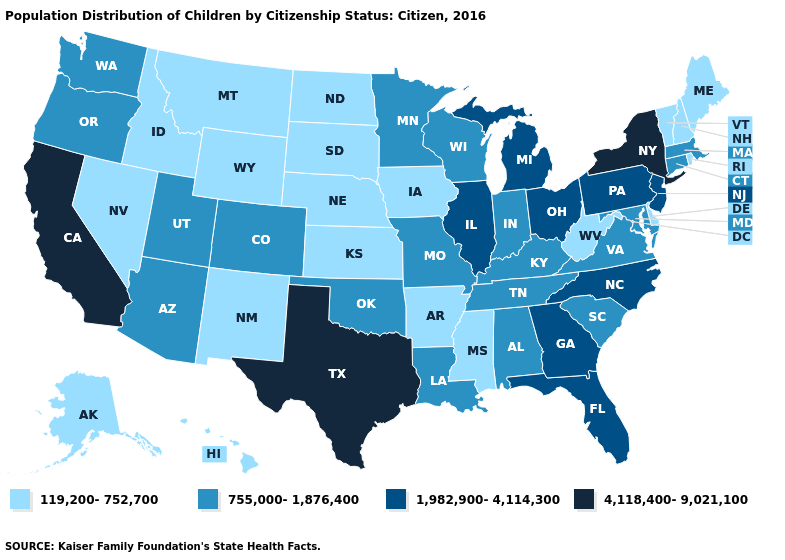Name the states that have a value in the range 755,000-1,876,400?
Write a very short answer. Alabama, Arizona, Colorado, Connecticut, Indiana, Kentucky, Louisiana, Maryland, Massachusetts, Minnesota, Missouri, Oklahoma, Oregon, South Carolina, Tennessee, Utah, Virginia, Washington, Wisconsin. What is the value of New Mexico?
Give a very brief answer. 119,200-752,700. Does Georgia have the same value as New York?
Keep it brief. No. What is the highest value in the West ?
Write a very short answer. 4,118,400-9,021,100. Name the states that have a value in the range 4,118,400-9,021,100?
Write a very short answer. California, New York, Texas. Does Ohio have the highest value in the MidWest?
Be succinct. Yes. Does Idaho have the lowest value in the West?
Give a very brief answer. Yes. Which states have the lowest value in the USA?
Concise answer only. Alaska, Arkansas, Delaware, Hawaii, Idaho, Iowa, Kansas, Maine, Mississippi, Montana, Nebraska, Nevada, New Hampshire, New Mexico, North Dakota, Rhode Island, South Dakota, Vermont, West Virginia, Wyoming. Name the states that have a value in the range 4,118,400-9,021,100?
Short answer required. California, New York, Texas. What is the value of Connecticut?
Be succinct. 755,000-1,876,400. What is the lowest value in the USA?
Write a very short answer. 119,200-752,700. What is the value of Utah?
Keep it brief. 755,000-1,876,400. Does New York have a higher value than Texas?
Short answer required. No. What is the value of Wyoming?
Concise answer only. 119,200-752,700. Which states have the lowest value in the USA?
Concise answer only. Alaska, Arkansas, Delaware, Hawaii, Idaho, Iowa, Kansas, Maine, Mississippi, Montana, Nebraska, Nevada, New Hampshire, New Mexico, North Dakota, Rhode Island, South Dakota, Vermont, West Virginia, Wyoming. 